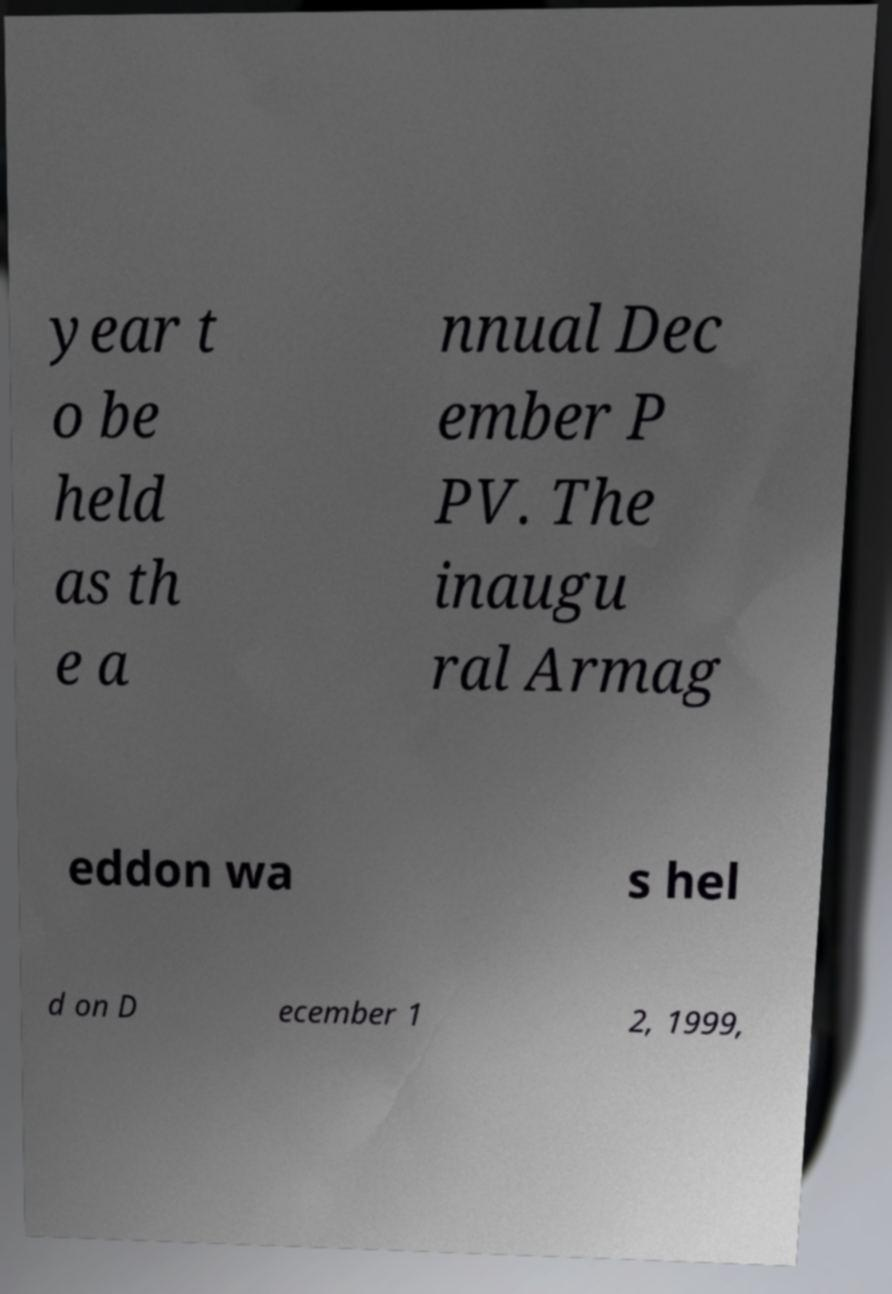Please read and relay the text visible in this image. What does it say? year t o be held as th e a nnual Dec ember P PV. The inaugu ral Armag eddon wa s hel d on D ecember 1 2, 1999, 